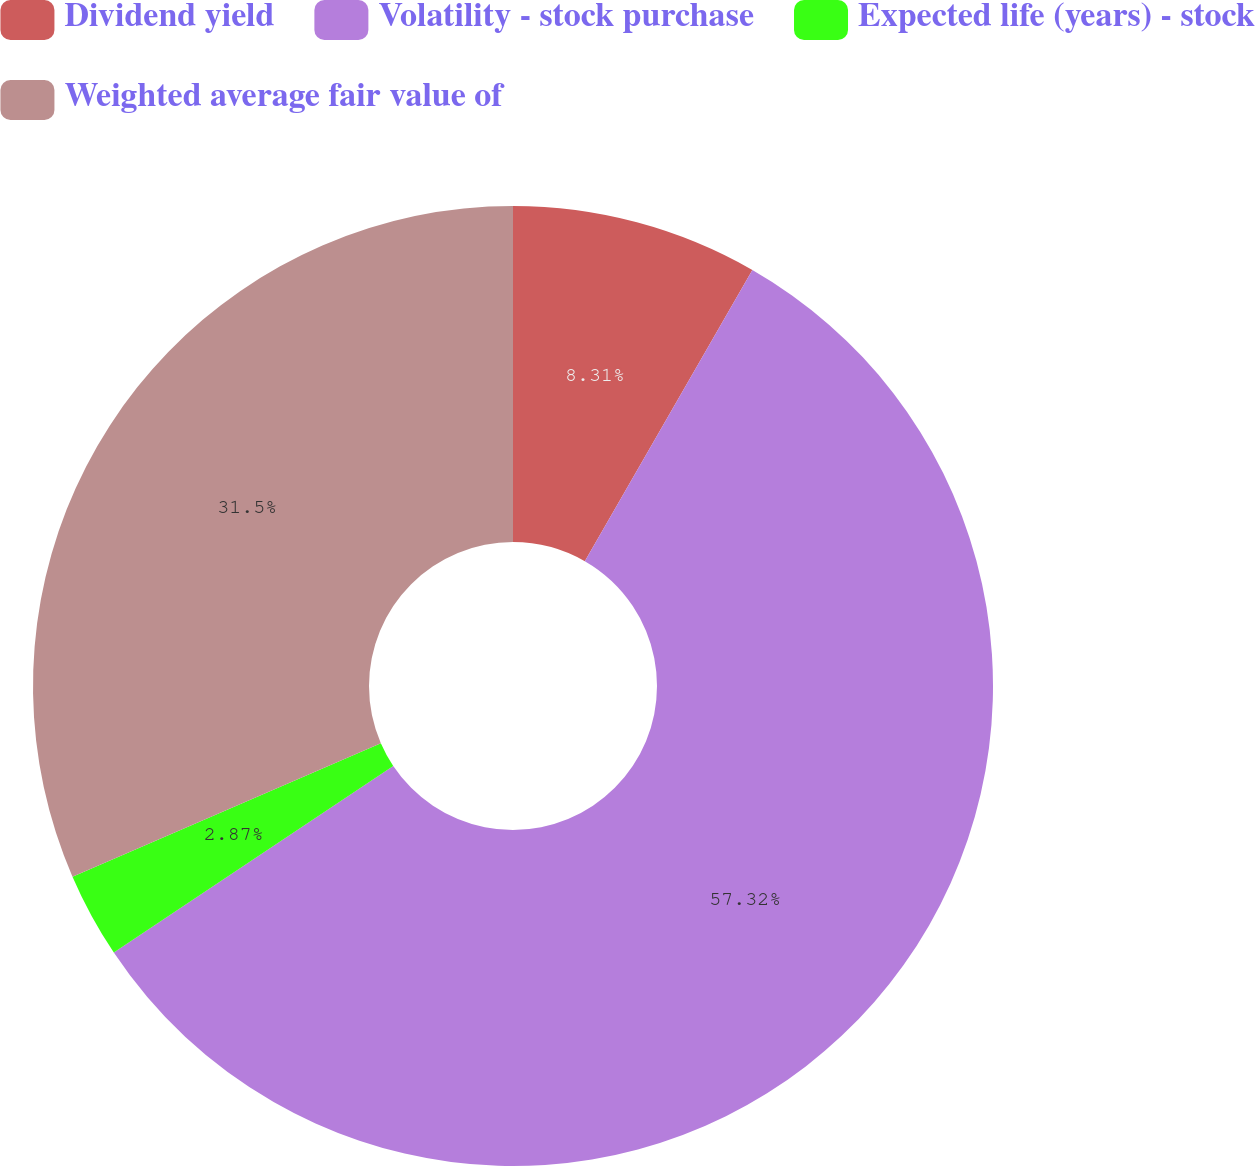Convert chart. <chart><loc_0><loc_0><loc_500><loc_500><pie_chart><fcel>Dividend yield<fcel>Volatility - stock purchase<fcel>Expected life (years) - stock<fcel>Weighted average fair value of<nl><fcel>8.31%<fcel>57.32%<fcel>2.87%<fcel>31.5%<nl></chart> 